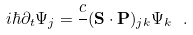Convert formula to latex. <formula><loc_0><loc_0><loc_500><loc_500>i \hbar { \partial } _ { t } \Psi _ { j } = \frac { c } { } ( { \mathbf S } \cdot { \mathbf P } ) _ { j k } \Psi _ { k } \ .</formula> 